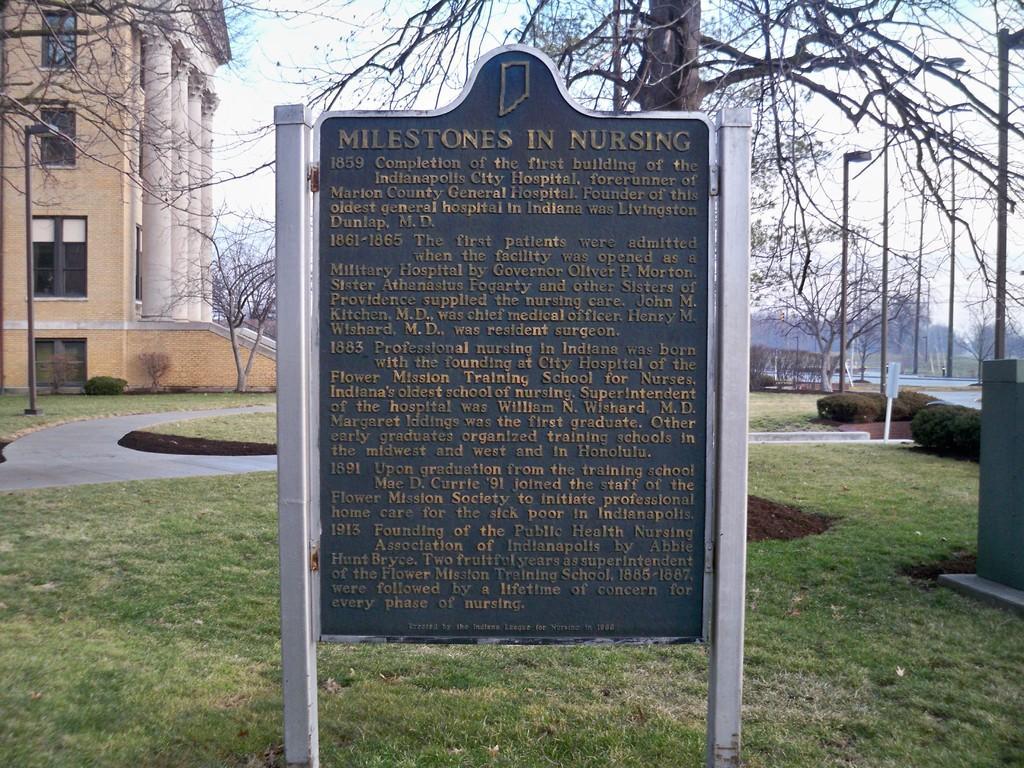How would you summarize this image in a sentence or two? In the middle I can see a board. In the background I can see grass, light poles, trees, building and the sky. This image is taken during a day. 